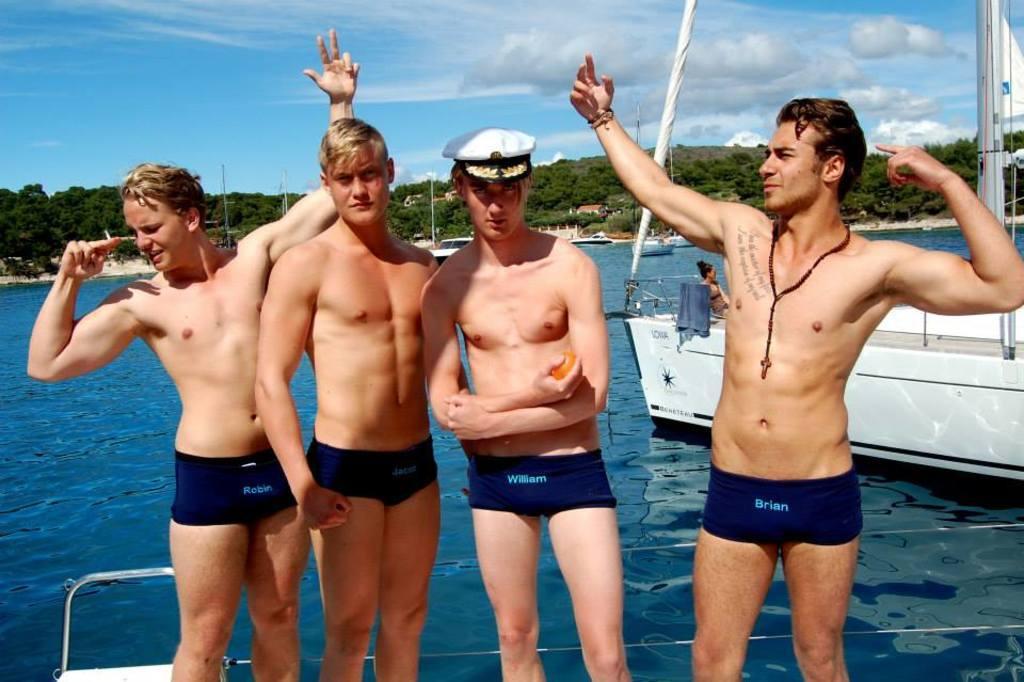How would you summarize this image in a sentence or two? In this image at front there are four persons standing on the ship. Behind her there is another ship. At the back side there is water. At the background there are trees, buildings, towers and at the top there is sky. 